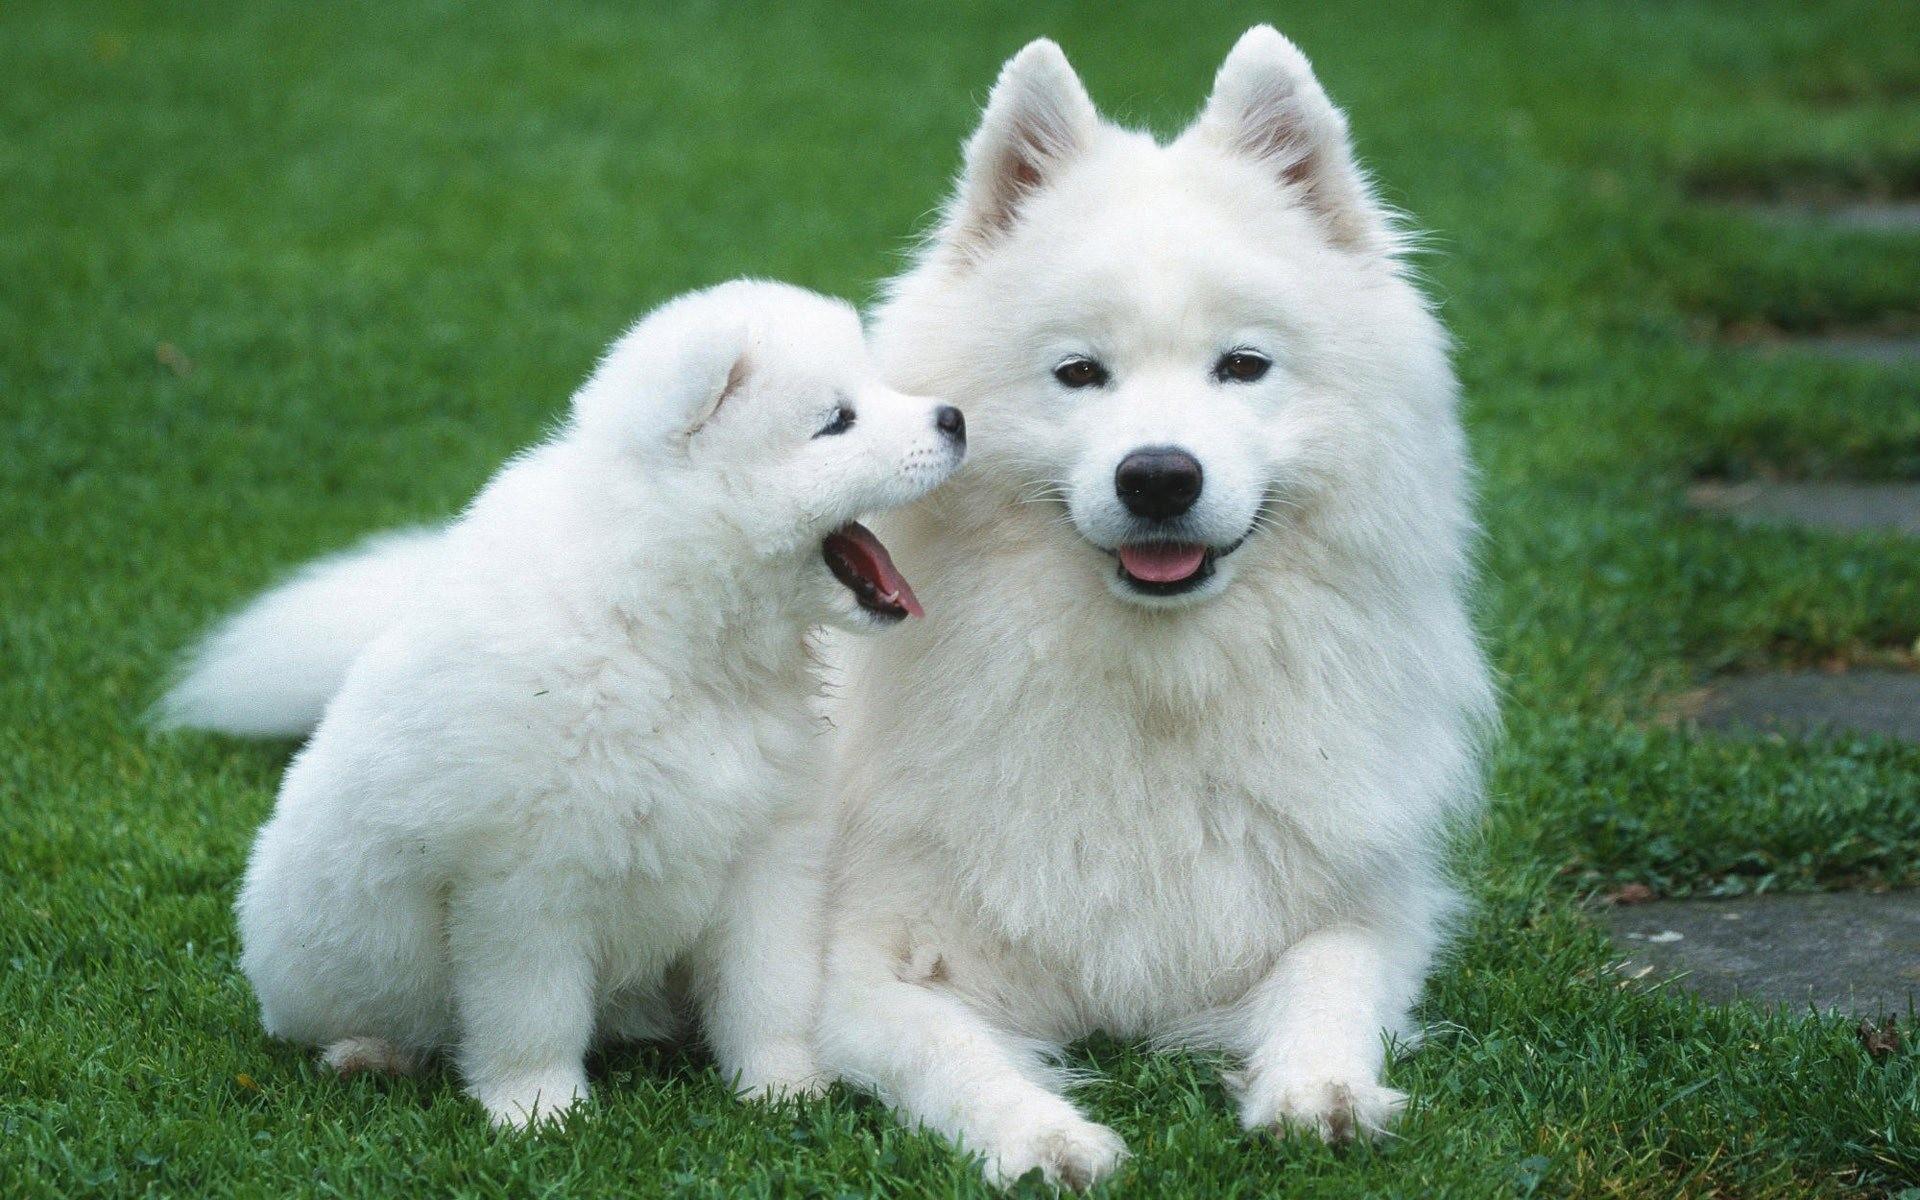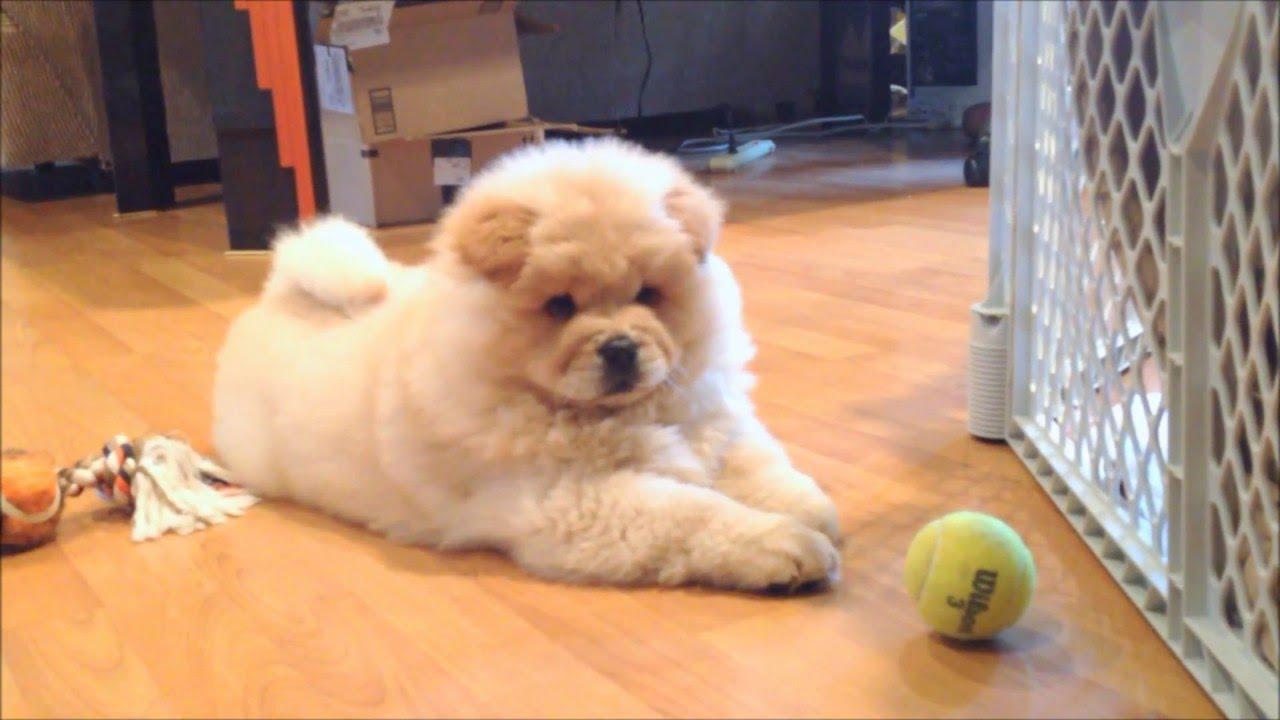The first image is the image on the left, the second image is the image on the right. Assess this claim about the two images: "There is one black dog". Correct or not? Answer yes or no. No. 